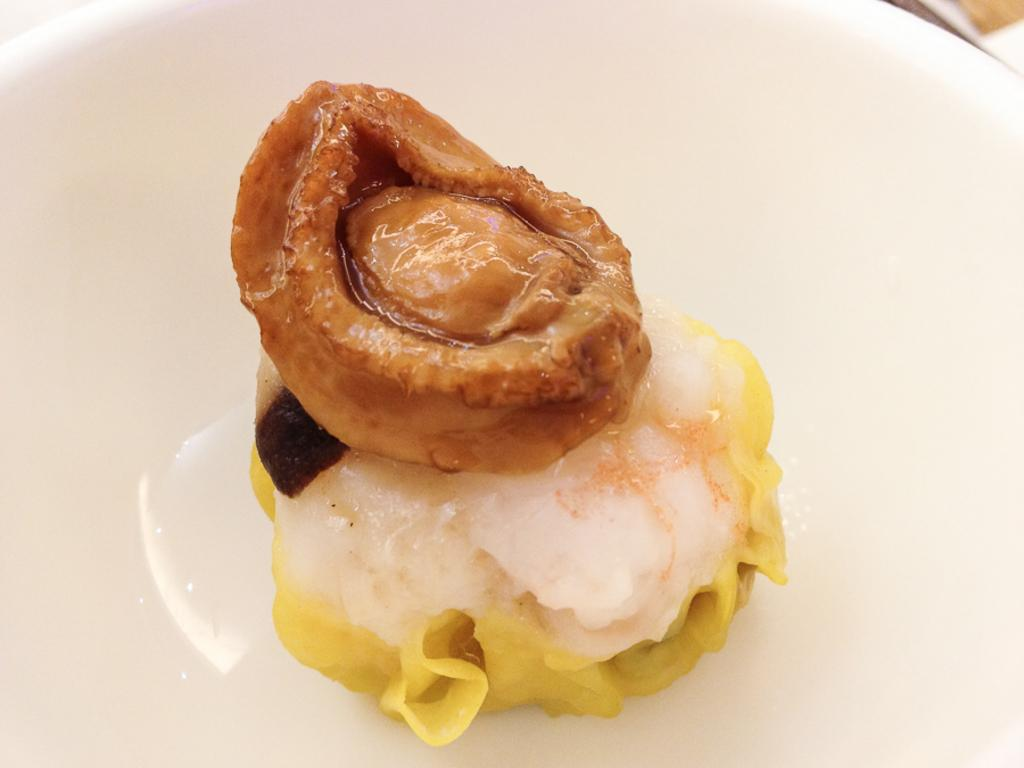What is present on the plate in the image? There are food items on a plate in the image. What type of paint is being used on the chair in the image? There is no chair or paint present in the image; it only features food items on a plate. 